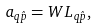Convert formula to latex. <formula><loc_0><loc_0><loc_500><loc_500>a _ { q \hat { p } } = W L _ { q \hat { p } } ,</formula> 